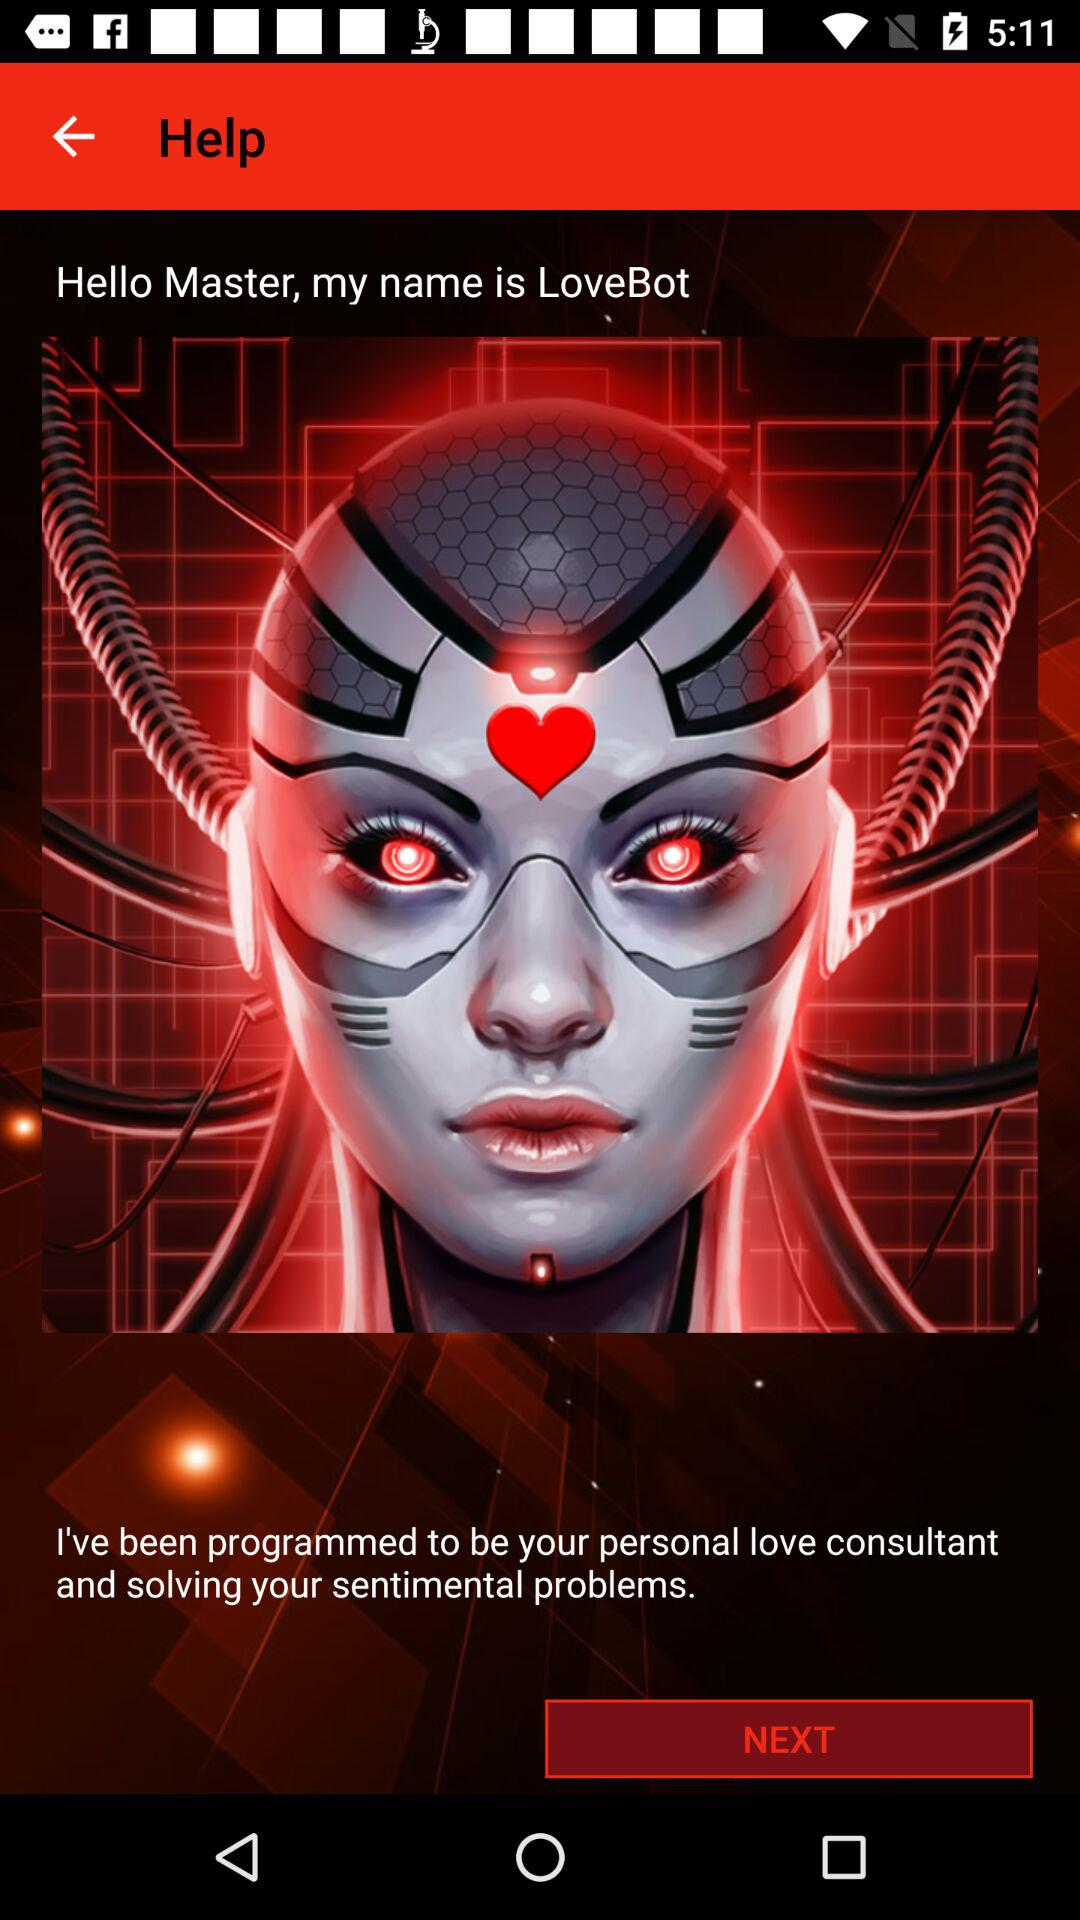What is the given name? The given name is "LoveBot". 